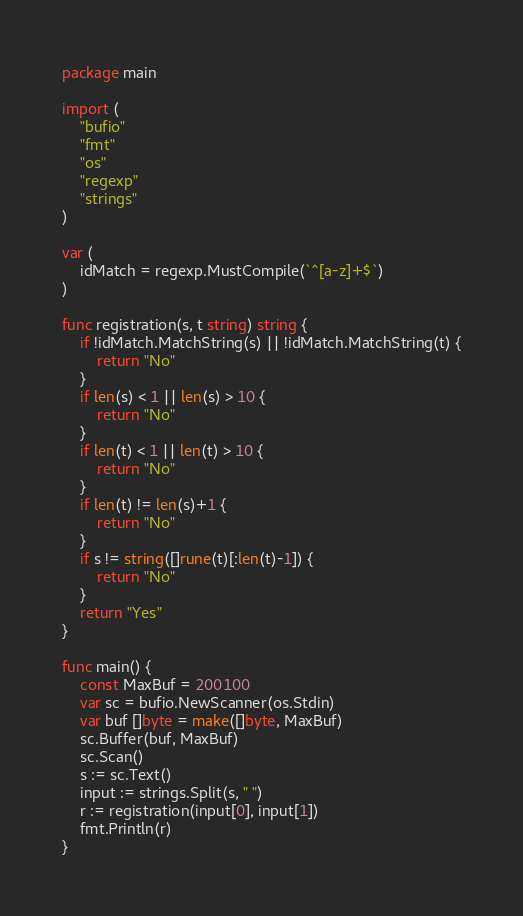<code> <loc_0><loc_0><loc_500><loc_500><_Go_>package main

import (
	"bufio"
	"fmt"
	"os"
	"regexp"
	"strings"
)

var (
	idMatch = regexp.MustCompile(`^[a-z]+$`)
)

func registration(s, t string) string {
	if !idMatch.MatchString(s) || !idMatch.MatchString(t) {
		return "No"
	}
	if len(s) < 1 || len(s) > 10 {
		return "No"
	}
	if len(t) < 1 || len(t) > 10 {
		return "No"
	}
	if len(t) != len(s)+1 {
		return "No"
	}
	if s != string([]rune(t)[:len(t)-1]) {
		return "No"
	}
	return "Yes"
}

func main() {
	const MaxBuf = 200100
	var sc = bufio.NewScanner(os.Stdin)
	var buf []byte = make([]byte, MaxBuf)
	sc.Buffer(buf, MaxBuf)
	sc.Scan()
	s := sc.Text()
	input := strings.Split(s, " ")
	r := registration(input[0], input[1])
	fmt.Println(r)
}</code> 